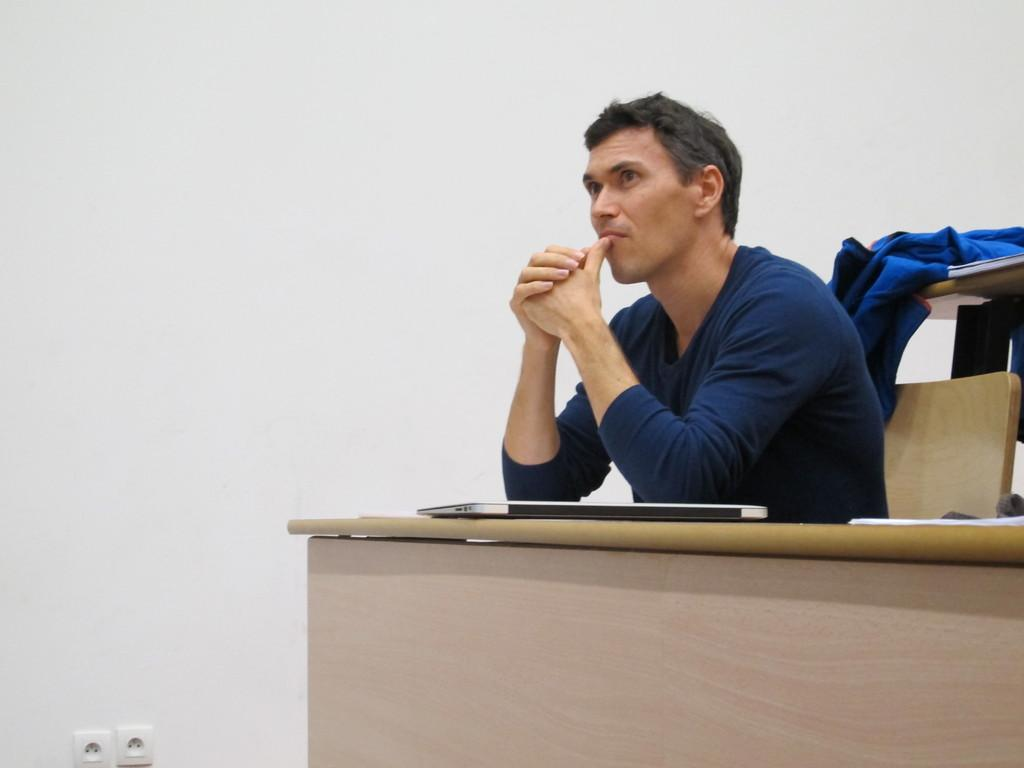Who is present in the image? There is a man in the image. What is the man doing in the image? The man is sitting on a chair in the image. What object can be seen on the table in the image? There is a laptop on the table in the image. What is the background of the image? There is a wall in the image. What type of animals can be seen at the zoo in the image? There is no zoo or animals present in the image; it features a man sitting on a chair with a laptop on a table. What type of iron is visible on the wall in the image? There is no iron visible on the wall in the image. 